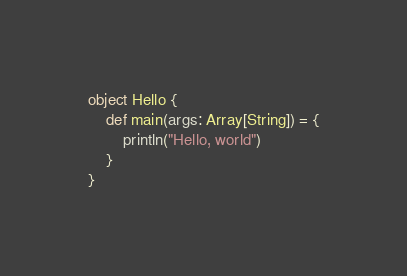<code> <loc_0><loc_0><loc_500><loc_500><_Scala_>object Hello {
    def main(args: Array[String]) = {
        println("Hello, world")
    }
}
</code> 